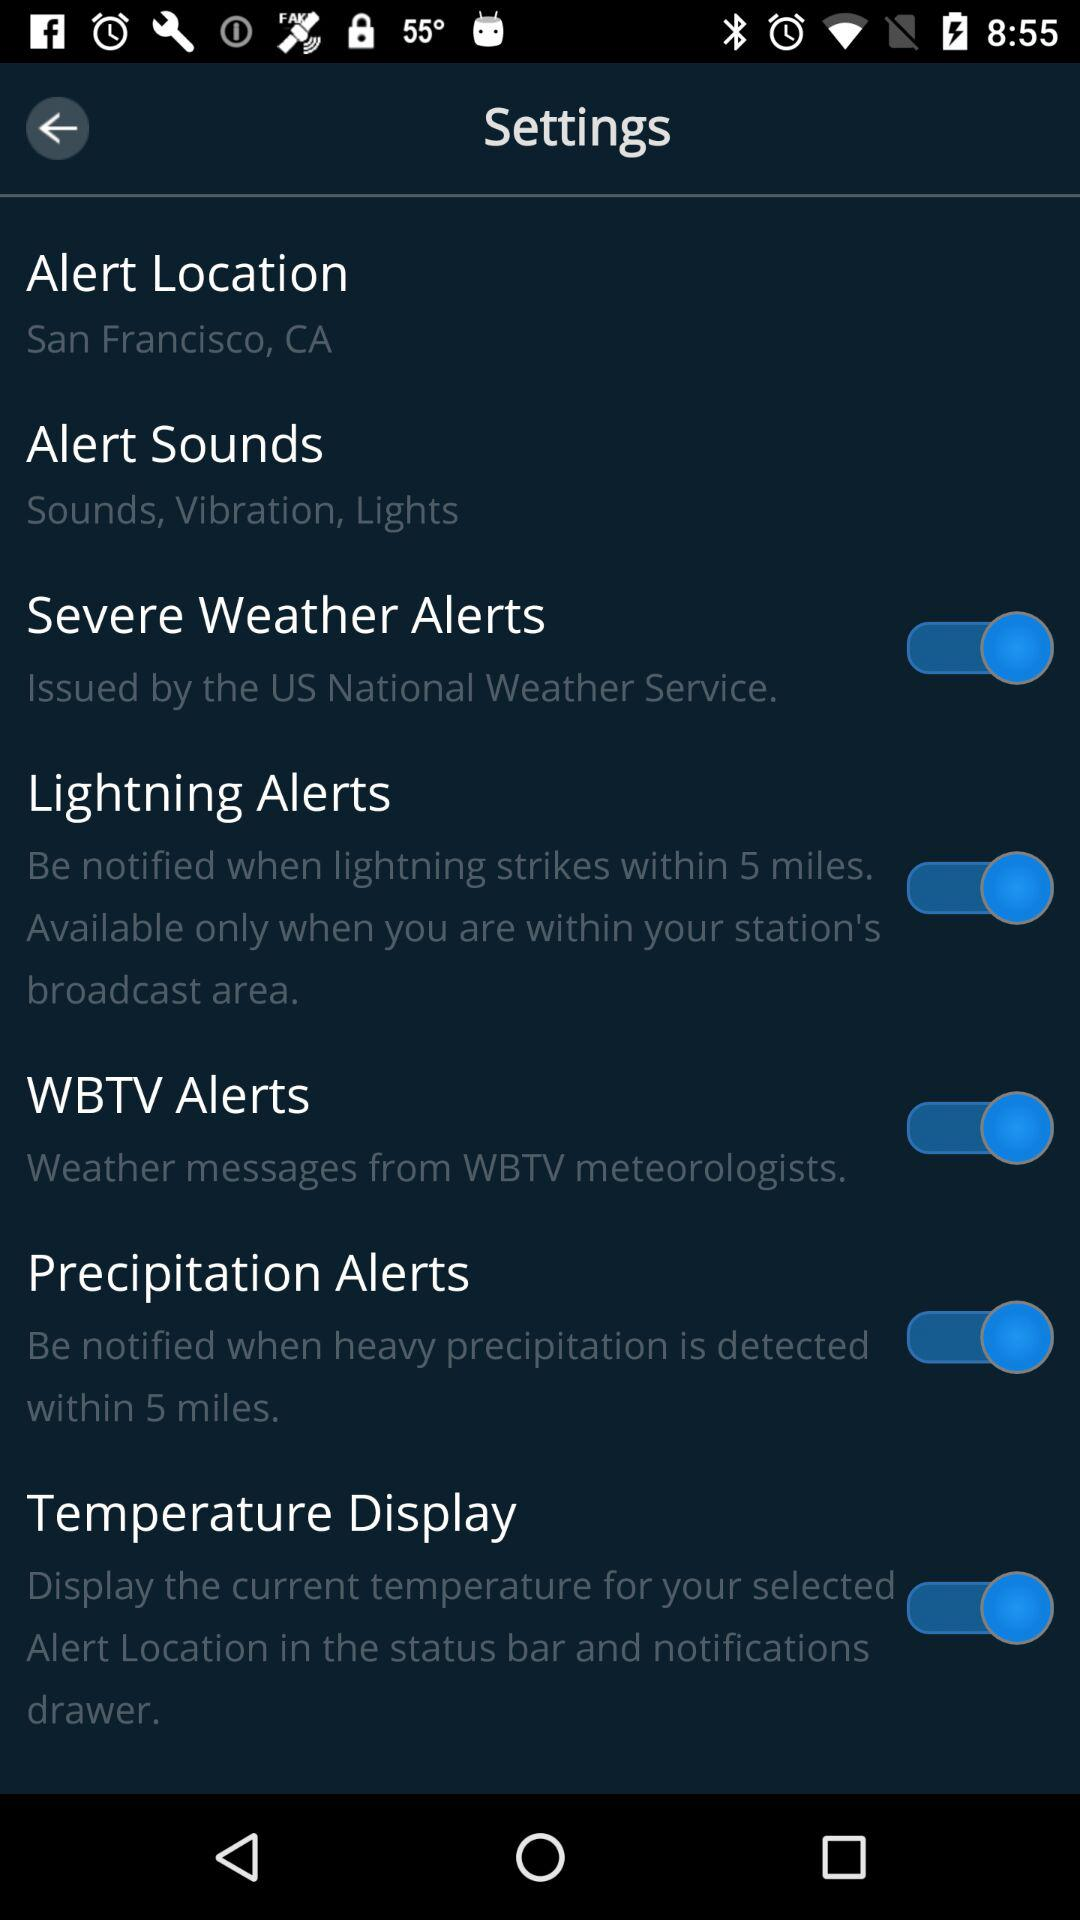How many alerts can be toggled on or off?
Answer the question using a single word or phrase. 4 